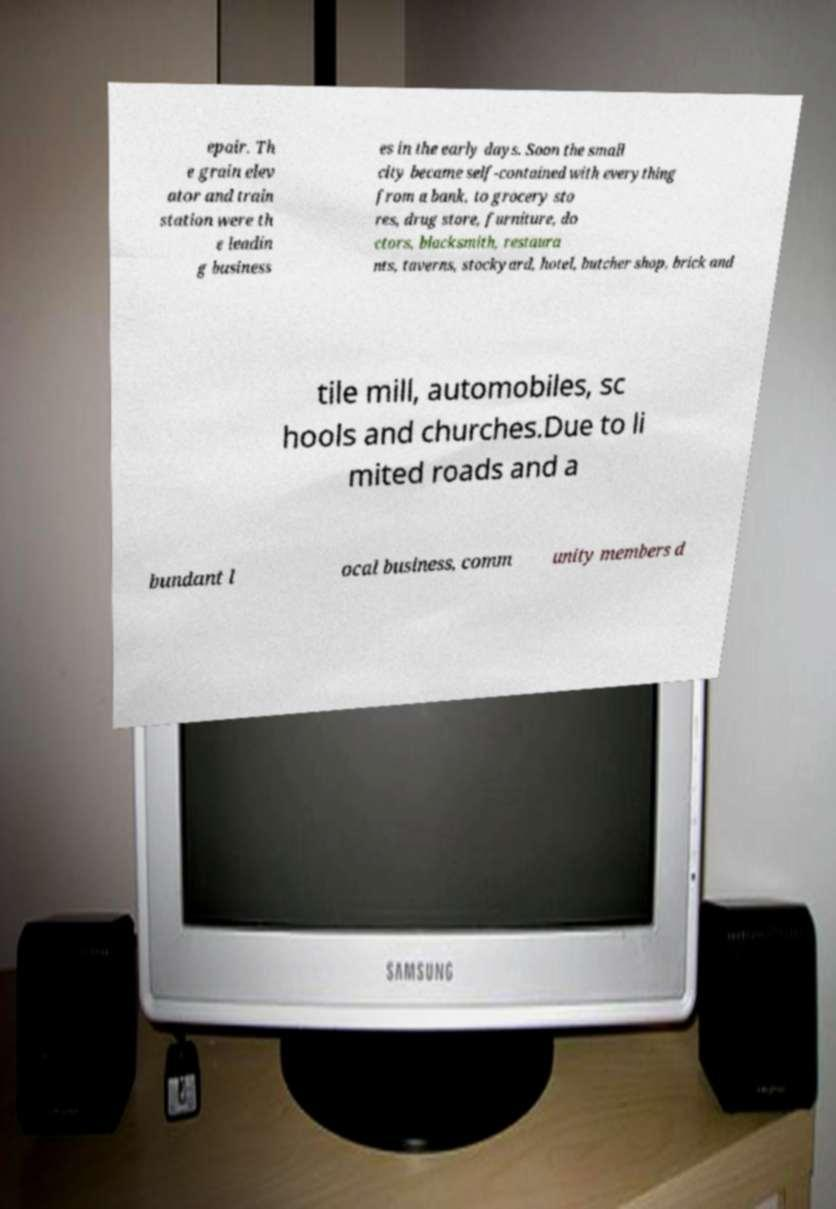Please read and relay the text visible in this image. What does it say? epair. Th e grain elev ator and train station were th e leadin g business es in the early days. Soon the small city became self-contained with everything from a bank, to grocery sto res, drug store, furniture, do ctors, blacksmith, restaura nts, taverns, stockyard, hotel, butcher shop, brick and tile mill, automobiles, sc hools and churches.Due to li mited roads and a bundant l ocal business, comm unity members d 